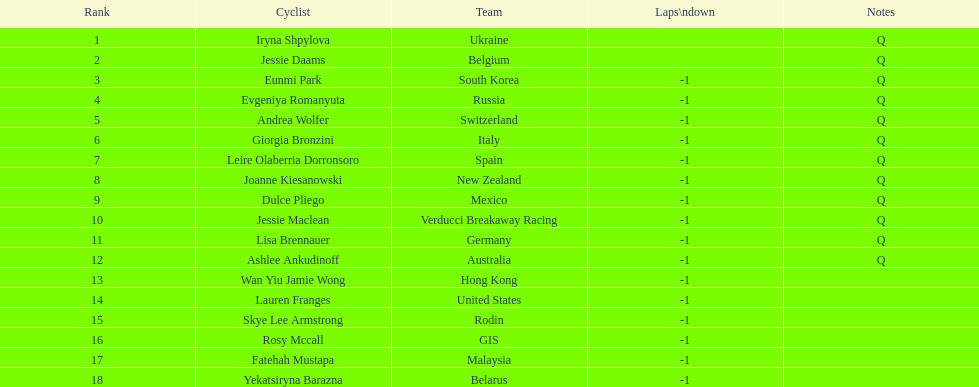Which competitor ended up in a higher position than jessie maclean? Dulce Pliego. 